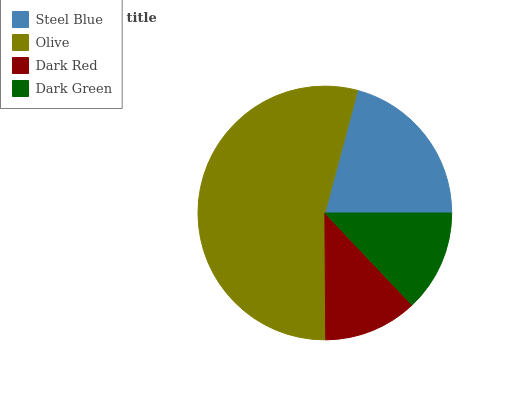Is Dark Red the minimum?
Answer yes or no. Yes. Is Olive the maximum?
Answer yes or no. Yes. Is Olive the minimum?
Answer yes or no. No. Is Dark Red the maximum?
Answer yes or no. No. Is Olive greater than Dark Red?
Answer yes or no. Yes. Is Dark Red less than Olive?
Answer yes or no. Yes. Is Dark Red greater than Olive?
Answer yes or no. No. Is Olive less than Dark Red?
Answer yes or no. No. Is Steel Blue the high median?
Answer yes or no. Yes. Is Dark Green the low median?
Answer yes or no. Yes. Is Dark Green the high median?
Answer yes or no. No. Is Dark Red the low median?
Answer yes or no. No. 